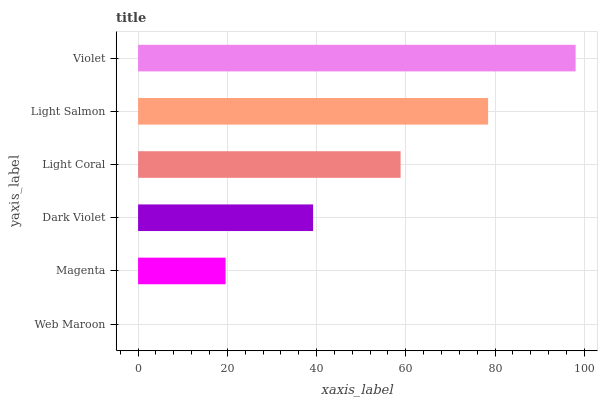Is Web Maroon the minimum?
Answer yes or no. Yes. Is Violet the maximum?
Answer yes or no. Yes. Is Magenta the minimum?
Answer yes or no. No. Is Magenta the maximum?
Answer yes or no. No. Is Magenta greater than Web Maroon?
Answer yes or no. Yes. Is Web Maroon less than Magenta?
Answer yes or no. Yes. Is Web Maroon greater than Magenta?
Answer yes or no. No. Is Magenta less than Web Maroon?
Answer yes or no. No. Is Light Coral the high median?
Answer yes or no. Yes. Is Dark Violet the low median?
Answer yes or no. Yes. Is Dark Violet the high median?
Answer yes or no. No. Is Light Salmon the low median?
Answer yes or no. No. 